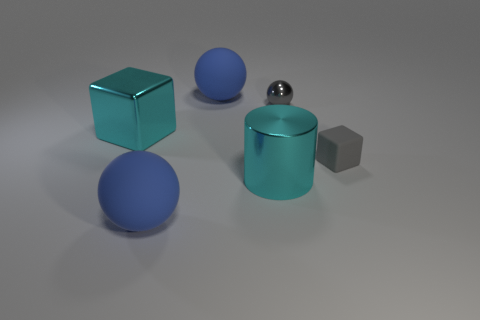What is the color of the shiny cylinder right of the big rubber thing that is behind the big cyan block that is on the left side of the metallic sphere?
Provide a short and direct response. Cyan. How many objects are blue spheres behind the big cylinder or gray rubber blocks?
Offer a terse response. 2. There is a cyan cube that is the same size as the metallic cylinder; what material is it?
Keep it short and to the point. Metal. What is the material of the large blue thing behind the large blue matte object that is left of the blue matte object behind the small ball?
Offer a very short reply. Rubber. The small rubber thing has what color?
Offer a very short reply. Gray. How many big objects are either brown metallic balls or rubber balls?
Provide a short and direct response. 2. What material is the big object that is the same color as the metal cylinder?
Your answer should be very brief. Metal. Is the tiny thing to the left of the gray matte thing made of the same material as the cyan thing behind the big cyan metal cylinder?
Your response must be concise. Yes. Are any big purple rubber things visible?
Offer a very short reply. No. Are there more matte objects in front of the gray rubber cube than metallic things that are on the left side of the large cyan cylinder?
Offer a terse response. No. 